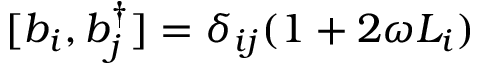Convert formula to latex. <formula><loc_0><loc_0><loc_500><loc_500>[ b _ { i } , b _ { j } ^ { \dagger } ] = \delta _ { i j } ( 1 + 2 \omega L _ { i } )</formula> 